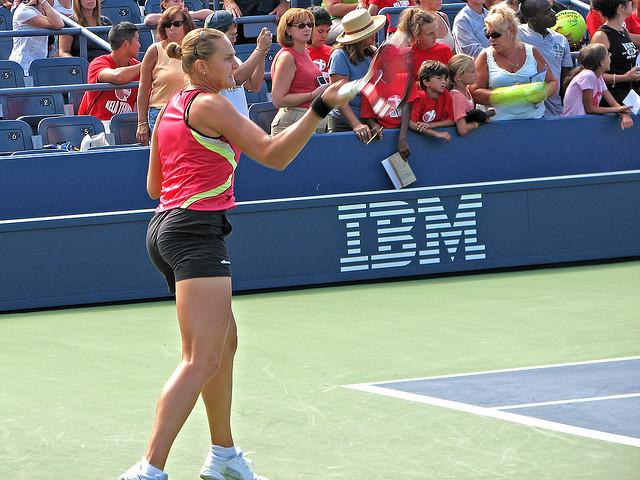Are all the seats full?
Be succinct. No. What is the company on the wall?
Write a very short answer. Ibm. What is the lady about to do?
Be succinct. Serve. Is the woman tired?
Keep it brief. Yes. 